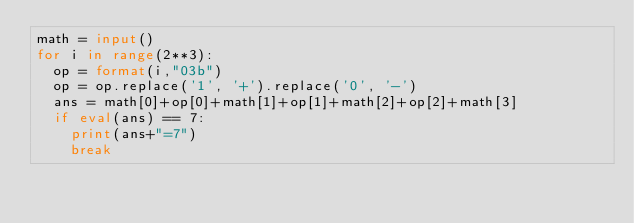Convert code to text. <code><loc_0><loc_0><loc_500><loc_500><_Python_>math = input()
for i in range(2**3):
  op = format(i,"03b")
  op = op.replace('1', '+').replace('0', '-')
  ans = math[0]+op[0]+math[1]+op[1]+math[2]+op[2]+math[3]
  if eval(ans) == 7:
    print(ans+"=7")
    break
</code> 